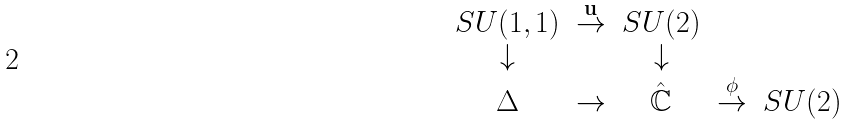Convert formula to latex. <formula><loc_0><loc_0><loc_500><loc_500>\begin{matrix} S U ( 1 , 1 ) & \overset { \mathbf u } \to & S U ( 2 ) \\ \downarrow & & \downarrow \\ \Delta & \to & \hat { \mathbb { C } } & \overset { \phi } \to & S U ( 2 ) \end{matrix}</formula> 